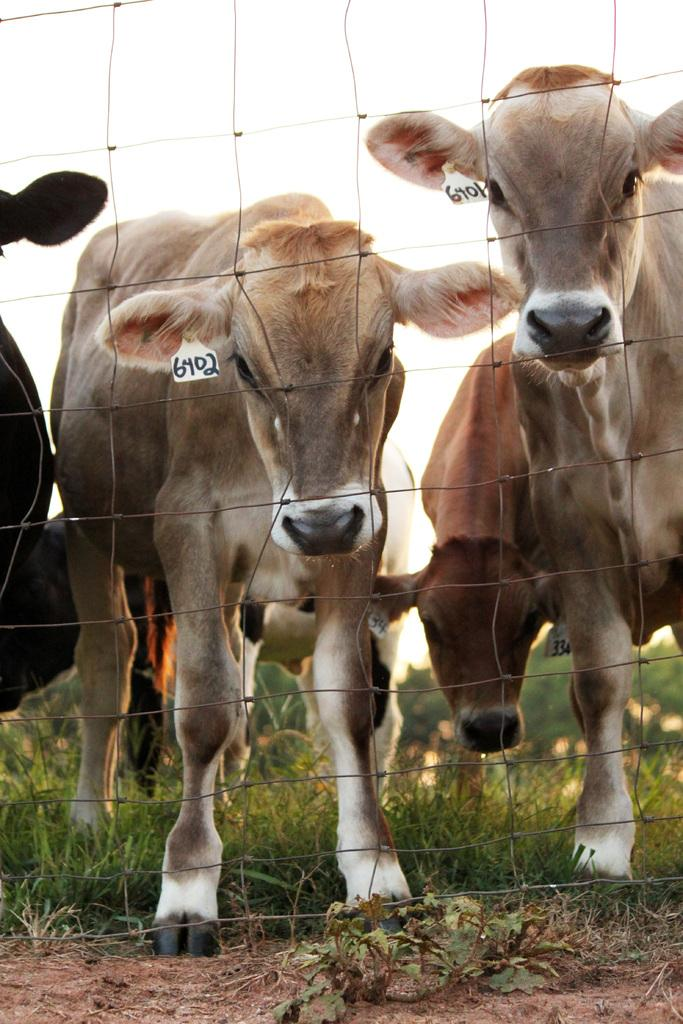What animals can be seen in the image? There are cows in the image. What is on the cows in the image? There are stickers on the cows. What type of material is visible in the image? There is a mesh in the image. What type of vegetation covers the ground in the image? The ground is covered with grass in the image. Can you tell me how many cows are flying in the image? There are no cows flying in the image; they are standing on the grass-covered ground. What type of field is visible in the image? There is no specific field mentioned or visible in the image; it simply shows cows with stickers on them, a mesh, and grass-covered ground. 